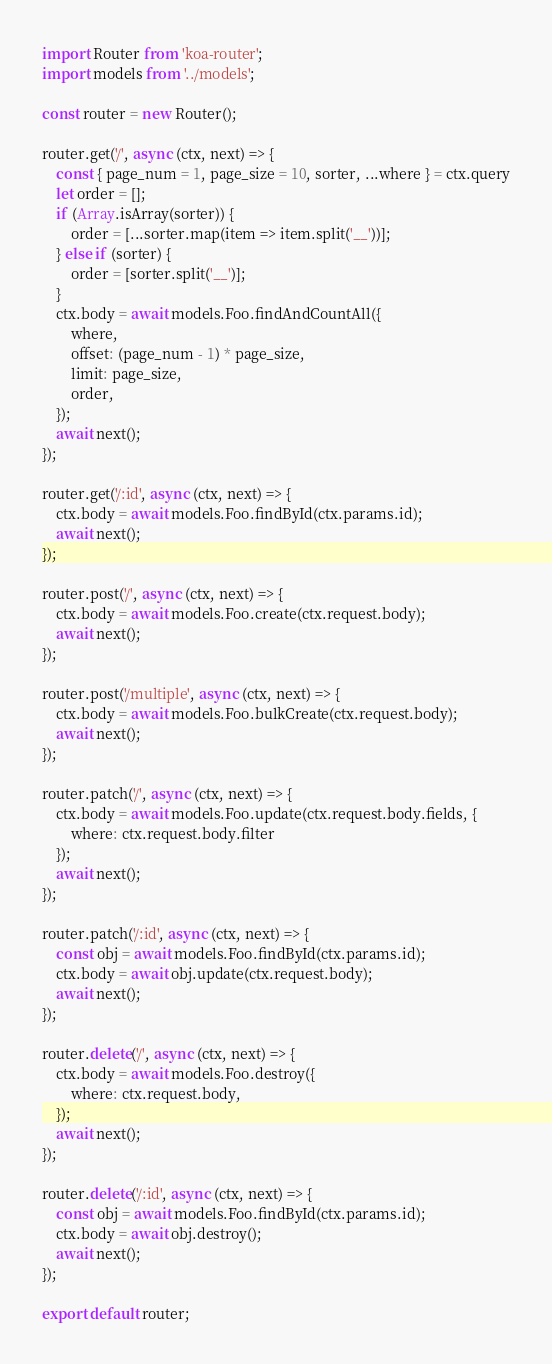Convert code to text. <code><loc_0><loc_0><loc_500><loc_500><_JavaScript_>import Router from 'koa-router';
import models from '../models';

const router = new Router();

router.get('/', async (ctx, next) => {
	const { page_num = 1, page_size = 10, sorter, ...where } = ctx.query
	let order = [];
	if (Array.isArray(sorter)) {
		order = [...sorter.map(item => item.split('__'))];
	} else if (sorter) {
		order = [sorter.split('__')];
	}
	ctx.body = await models.Foo.findAndCountAll({
		where,
		offset: (page_num - 1) * page_size,
		limit: page_size,
		order,
	});
	await next();
});

router.get('/:id', async (ctx, next) => {
	ctx.body = await models.Foo.findById(ctx.params.id);
	await next();
});

router.post('/', async (ctx, next) => {
	ctx.body = await models.Foo.create(ctx.request.body);
	await next();
});

router.post('/multiple', async (ctx, next) => {
	ctx.body = await models.Foo.bulkCreate(ctx.request.body);
	await next();
});

router.patch('/', async (ctx, next) => {
	ctx.body = await models.Foo.update(ctx.request.body.fields, {
		where: ctx.request.body.filter
	});
	await next();
});

router.patch('/:id', async (ctx, next) => {
	const obj = await models.Foo.findById(ctx.params.id);
	ctx.body = await obj.update(ctx.request.body);
	await next();
});

router.delete('/', async (ctx, next) => {
	ctx.body = await models.Foo.destroy({
		where: ctx.request.body,
	});
	await next();
});

router.delete('/:id', async (ctx, next) => {
	const obj = await models.Foo.findById(ctx.params.id);
	ctx.body = await obj.destroy();
	await next();
});

export default router;
</code> 